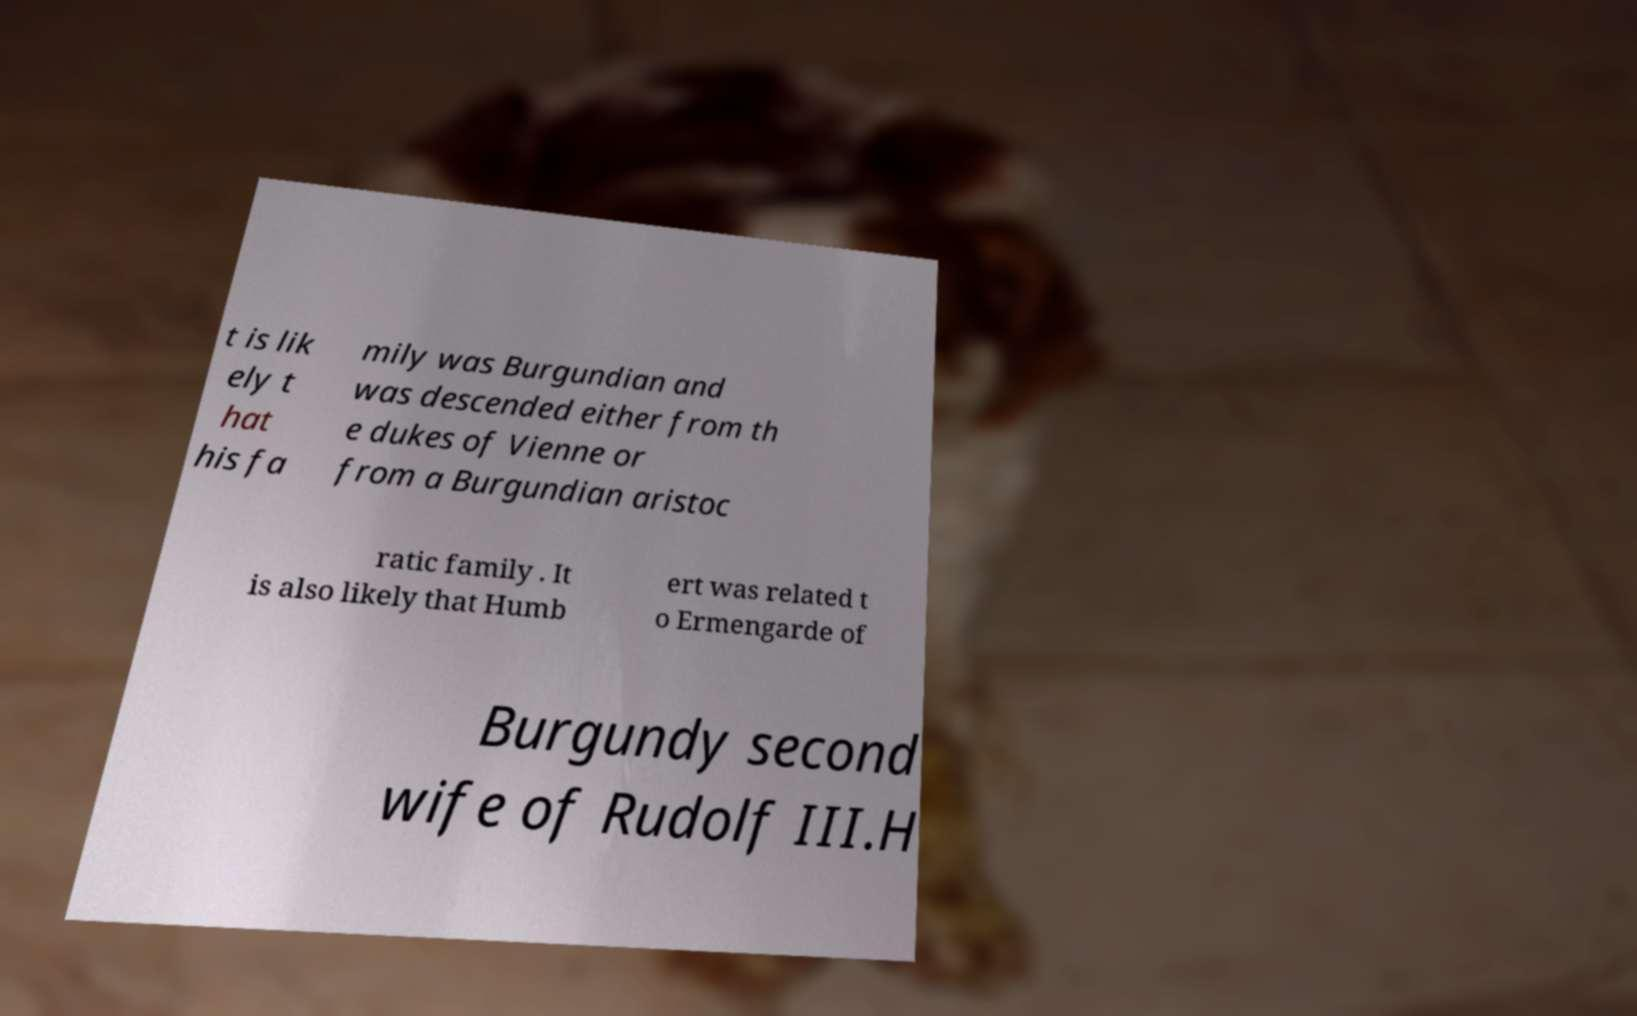Can you read and provide the text displayed in the image?This photo seems to have some interesting text. Can you extract and type it out for me? t is lik ely t hat his fa mily was Burgundian and was descended either from th e dukes of Vienne or from a Burgundian aristoc ratic family . It is also likely that Humb ert was related t o Ermengarde of Burgundy second wife of Rudolf III.H 